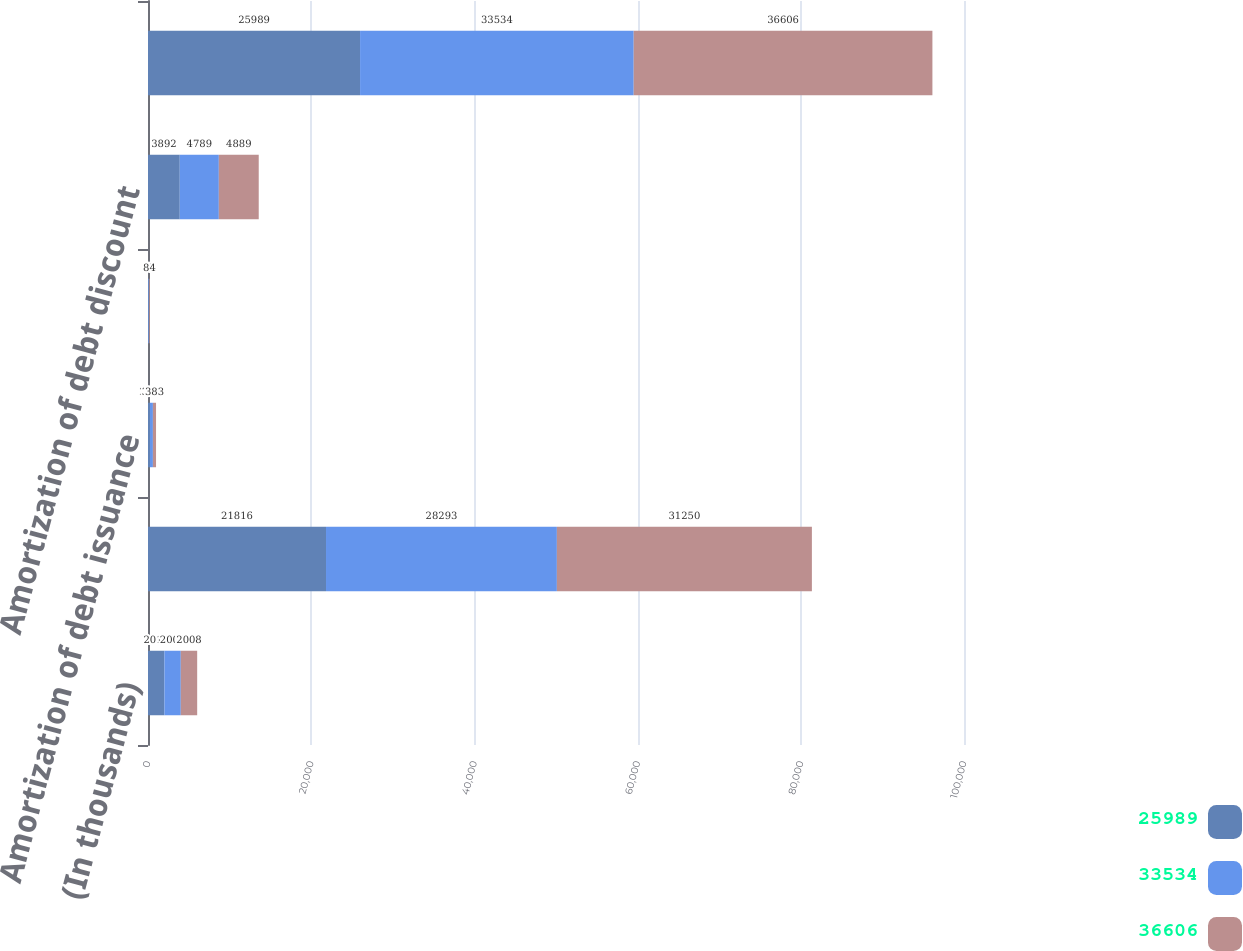Convert chart to OTSL. <chart><loc_0><loc_0><loc_500><loc_500><stacked_bar_chart><ecel><fcel>(In thousands)<fcel>Contractual coupon interest<fcel>Amortization of debt issuance<fcel>Amortization of embedded<fcel>Amortization of debt discount<fcel>Total interest expense related<nl><fcel>25989<fcel>2010<fcel>21816<fcel>223<fcel>58<fcel>3892<fcel>25989<nl><fcel>33534<fcel>2009<fcel>28293<fcel>379<fcel>73<fcel>4789<fcel>33534<nl><fcel>36606<fcel>2008<fcel>31250<fcel>383<fcel>84<fcel>4889<fcel>36606<nl></chart> 